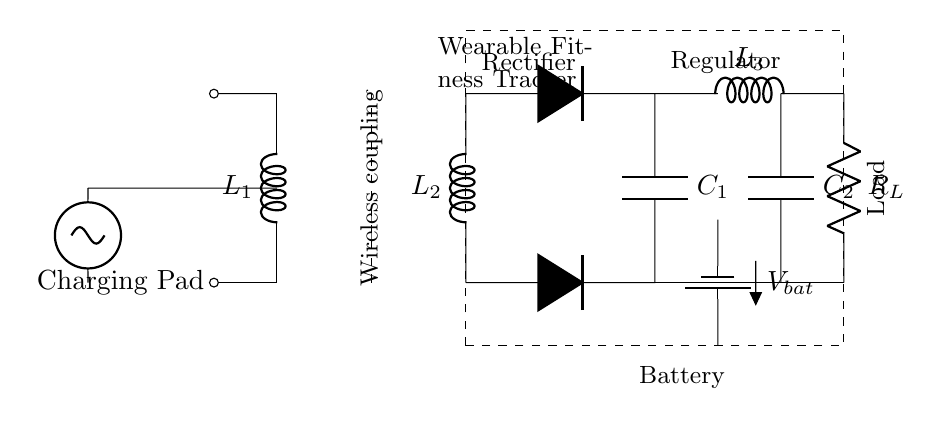What is the function of L1 in the circuit? L1 is a wireless charging coil that serves as a transmitter and is essential for creating an electromagnetic field that allows for the transfer of energy to the wearable device.
Answer: Wireless charging coil What is the purpose of the rectifier in this circuit? The rectifier converts alternating current (AC) generated from the transmitter's coil into direct current (DC), which is suitable for charging the battery and powering the wearable fitness tracker.
Answer: Converts AC to DC What is the voltage source type in the circuit? The circuit uses a sinusoidal voltage source, which provides an alternating current (AC) for the wireless charging process.
Answer: Sinusoidal voltage source How many coils are present in the circuit? There are two coils: L1 (transmitter) and L2 (receiver), which work together for wireless energy transfer.
Answer: Two coils What is the function of the battery in this circuit? The battery stores energy that is transferred from the charging pad and provides a power supply to the load (wearable device) when needed.
Answer: Energy storage What components are labeled as part of the load? The load consists of a resistor, which represents the microcontroller and other sensors in the wearable fitness tracker, indicating where the power is utilized.
Answer: Resistor (Load) What is the effect of the voltage regulator in this circuit? The voltage regulator ensures that the output voltage delivered to the load (wearable device) is stable and within the required specifications for proper device operation.
Answer: Stabilizes voltage 